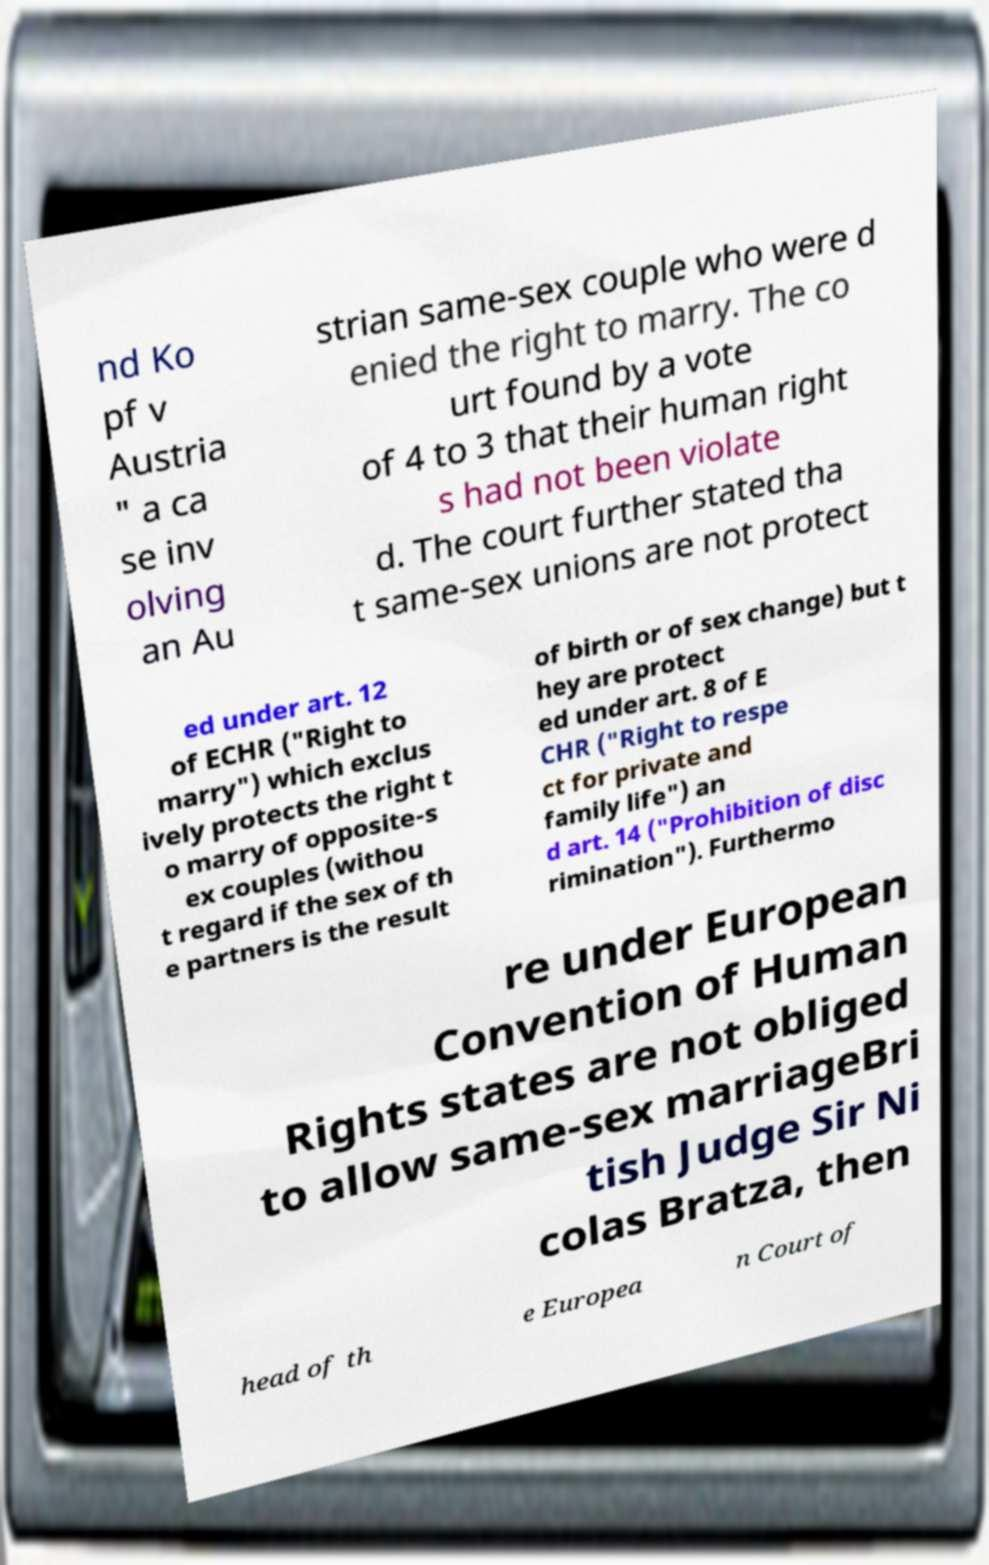For documentation purposes, I need the text within this image transcribed. Could you provide that? nd Ko pf v Austria " a ca se inv olving an Au strian same-sex couple who were d enied the right to marry. The co urt found by a vote of 4 to 3 that their human right s had not been violate d. The court further stated tha t same-sex unions are not protect ed under art. 12 of ECHR ("Right to marry") which exclus ively protects the right t o marry of opposite-s ex couples (withou t regard if the sex of th e partners is the result of birth or of sex change) but t hey are protect ed under art. 8 of E CHR ("Right to respe ct for private and family life") an d art. 14 ("Prohibition of disc rimination"). Furthermo re under European Convention of Human Rights states are not obliged to allow same-sex marriageBri tish Judge Sir Ni colas Bratza, then head of th e Europea n Court of 